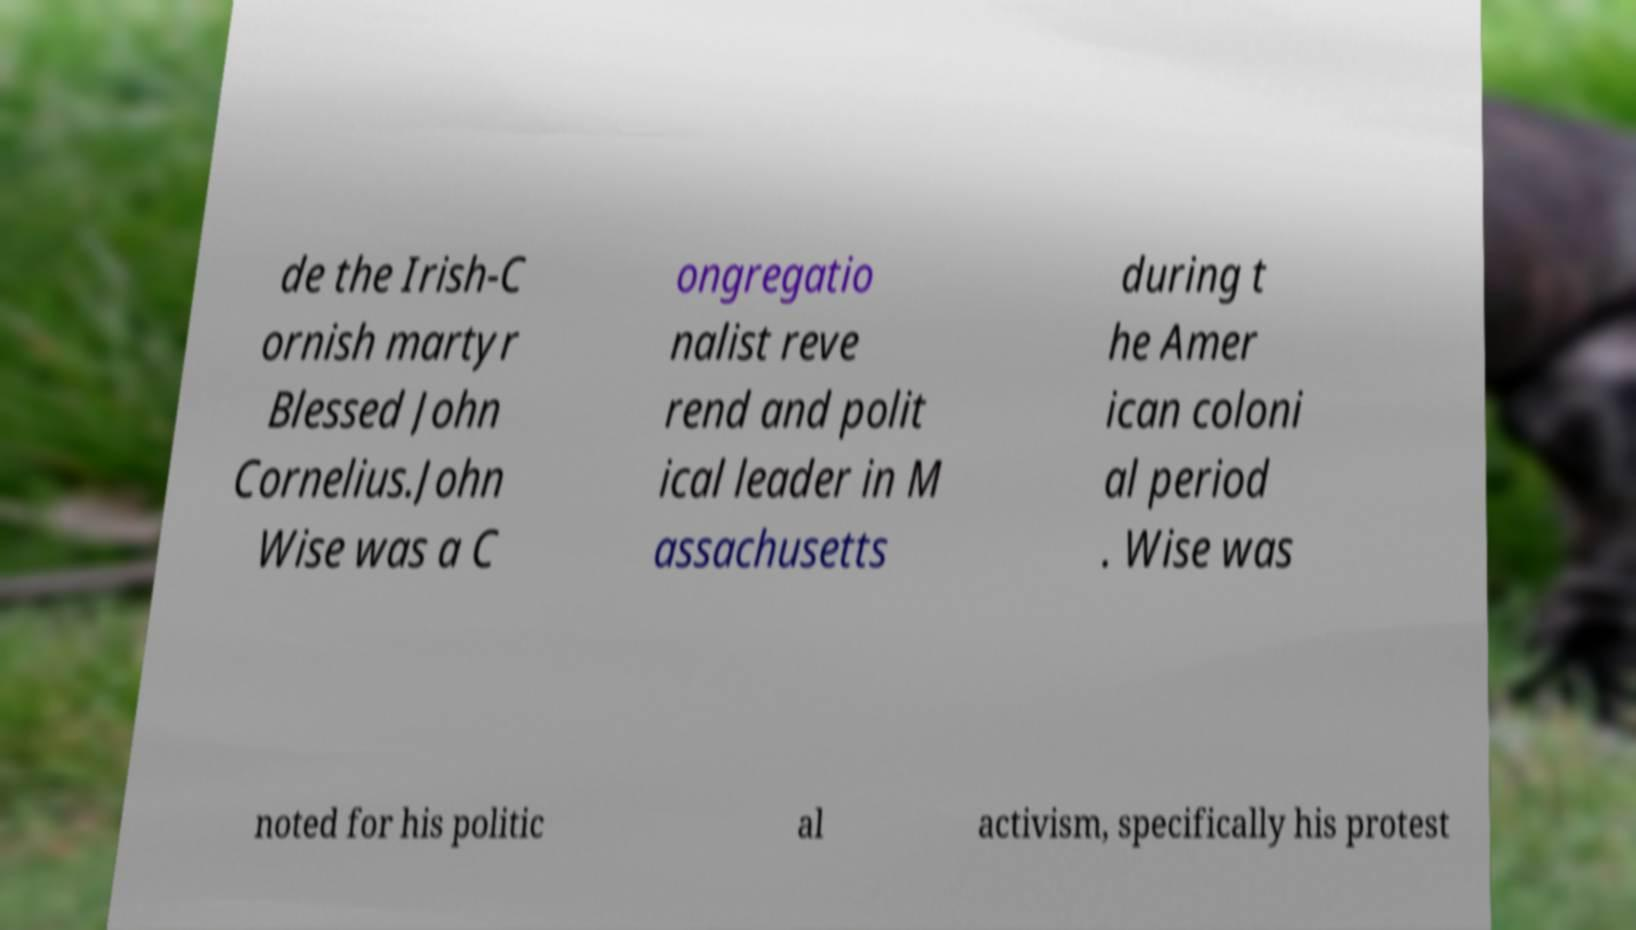Can you accurately transcribe the text from the provided image for me? de the Irish-C ornish martyr Blessed John Cornelius.John Wise was a C ongregatio nalist reve rend and polit ical leader in M assachusetts during t he Amer ican coloni al period . Wise was noted for his politic al activism, specifically his protest 